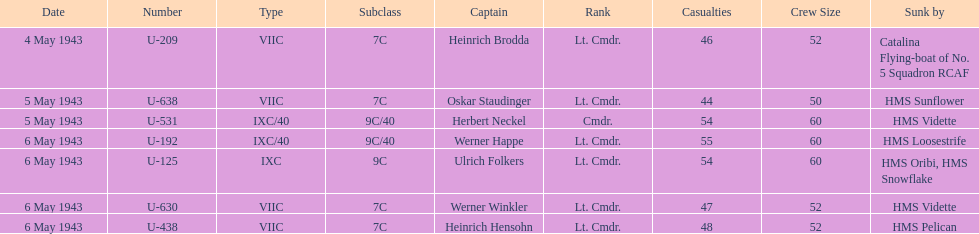Which sunken u-boat had the most casualties U-192. 